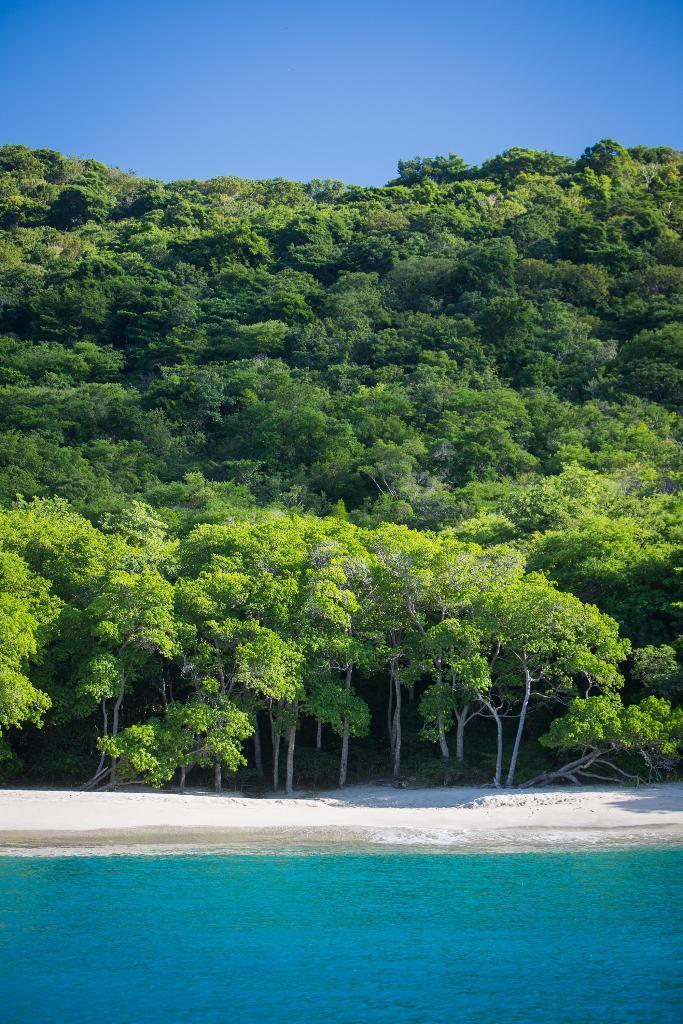In one or two sentences, can you explain what this image depicts? In this image we can see hill, trees, sand, water. In the background there is sky. 